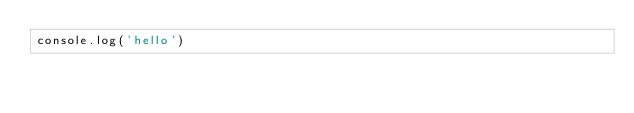Convert code to text. <code><loc_0><loc_0><loc_500><loc_500><_JavaScript_>console.log('hello')</code> 